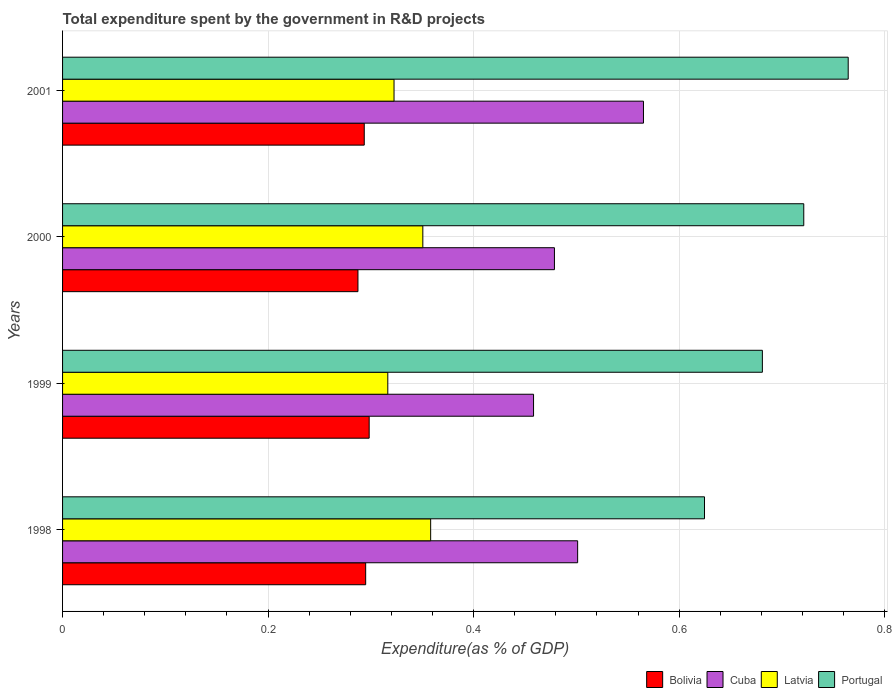How many different coloured bars are there?
Your answer should be compact. 4. How many groups of bars are there?
Your answer should be very brief. 4. Are the number of bars per tick equal to the number of legend labels?
Make the answer very short. Yes. Are the number of bars on each tick of the Y-axis equal?
Your answer should be compact. Yes. How many bars are there on the 2nd tick from the top?
Keep it short and to the point. 4. In how many cases, is the number of bars for a given year not equal to the number of legend labels?
Keep it short and to the point. 0. What is the total expenditure spent by the government in R&D projects in Latvia in 2000?
Your answer should be very brief. 0.35. Across all years, what is the maximum total expenditure spent by the government in R&D projects in Portugal?
Offer a very short reply. 0.76. Across all years, what is the minimum total expenditure spent by the government in R&D projects in Cuba?
Ensure brevity in your answer.  0.46. What is the total total expenditure spent by the government in R&D projects in Cuba in the graph?
Keep it short and to the point. 2. What is the difference between the total expenditure spent by the government in R&D projects in Latvia in 1999 and that in 2001?
Offer a terse response. -0.01. What is the difference between the total expenditure spent by the government in R&D projects in Bolivia in 2000 and the total expenditure spent by the government in R&D projects in Cuba in 2001?
Your answer should be compact. -0.28. What is the average total expenditure spent by the government in R&D projects in Bolivia per year?
Provide a succinct answer. 0.29. In the year 1999, what is the difference between the total expenditure spent by the government in R&D projects in Latvia and total expenditure spent by the government in R&D projects in Bolivia?
Your response must be concise. 0.02. In how many years, is the total expenditure spent by the government in R&D projects in Latvia greater than 0.16 %?
Make the answer very short. 4. What is the ratio of the total expenditure spent by the government in R&D projects in Portugal in 1999 to that in 2001?
Offer a terse response. 0.89. What is the difference between the highest and the second highest total expenditure spent by the government in R&D projects in Latvia?
Offer a very short reply. 0.01. What is the difference between the highest and the lowest total expenditure spent by the government in R&D projects in Portugal?
Provide a succinct answer. 0.14. Is the sum of the total expenditure spent by the government in R&D projects in Portugal in 1998 and 2001 greater than the maximum total expenditure spent by the government in R&D projects in Latvia across all years?
Provide a succinct answer. Yes. Is it the case that in every year, the sum of the total expenditure spent by the government in R&D projects in Cuba and total expenditure spent by the government in R&D projects in Bolivia is greater than the sum of total expenditure spent by the government in R&D projects in Latvia and total expenditure spent by the government in R&D projects in Portugal?
Your answer should be very brief. Yes. What does the 3rd bar from the top in 2001 represents?
Your answer should be very brief. Cuba. What does the 3rd bar from the bottom in 2001 represents?
Your answer should be very brief. Latvia. How many bars are there?
Offer a very short reply. 16. Are all the bars in the graph horizontal?
Give a very brief answer. Yes. Does the graph contain any zero values?
Keep it short and to the point. No. What is the title of the graph?
Keep it short and to the point. Total expenditure spent by the government in R&D projects. Does "Yemen, Rep." appear as one of the legend labels in the graph?
Your response must be concise. No. What is the label or title of the X-axis?
Provide a short and direct response. Expenditure(as % of GDP). What is the label or title of the Y-axis?
Offer a terse response. Years. What is the Expenditure(as % of GDP) of Bolivia in 1998?
Give a very brief answer. 0.29. What is the Expenditure(as % of GDP) of Cuba in 1998?
Ensure brevity in your answer.  0.5. What is the Expenditure(as % of GDP) in Latvia in 1998?
Give a very brief answer. 0.36. What is the Expenditure(as % of GDP) of Portugal in 1998?
Your answer should be very brief. 0.62. What is the Expenditure(as % of GDP) of Bolivia in 1999?
Your answer should be very brief. 0.3. What is the Expenditure(as % of GDP) of Cuba in 1999?
Your answer should be compact. 0.46. What is the Expenditure(as % of GDP) of Latvia in 1999?
Ensure brevity in your answer.  0.32. What is the Expenditure(as % of GDP) of Portugal in 1999?
Offer a very short reply. 0.68. What is the Expenditure(as % of GDP) of Bolivia in 2000?
Offer a terse response. 0.29. What is the Expenditure(as % of GDP) of Cuba in 2000?
Provide a short and direct response. 0.48. What is the Expenditure(as % of GDP) in Latvia in 2000?
Your answer should be very brief. 0.35. What is the Expenditure(as % of GDP) in Portugal in 2000?
Provide a succinct answer. 0.72. What is the Expenditure(as % of GDP) in Bolivia in 2001?
Keep it short and to the point. 0.29. What is the Expenditure(as % of GDP) of Cuba in 2001?
Provide a short and direct response. 0.57. What is the Expenditure(as % of GDP) of Latvia in 2001?
Provide a succinct answer. 0.32. What is the Expenditure(as % of GDP) of Portugal in 2001?
Offer a terse response. 0.76. Across all years, what is the maximum Expenditure(as % of GDP) in Bolivia?
Your answer should be very brief. 0.3. Across all years, what is the maximum Expenditure(as % of GDP) of Cuba?
Make the answer very short. 0.57. Across all years, what is the maximum Expenditure(as % of GDP) in Latvia?
Your response must be concise. 0.36. Across all years, what is the maximum Expenditure(as % of GDP) in Portugal?
Provide a short and direct response. 0.76. Across all years, what is the minimum Expenditure(as % of GDP) in Bolivia?
Offer a very short reply. 0.29. Across all years, what is the minimum Expenditure(as % of GDP) in Cuba?
Your answer should be compact. 0.46. Across all years, what is the minimum Expenditure(as % of GDP) of Latvia?
Provide a succinct answer. 0.32. Across all years, what is the minimum Expenditure(as % of GDP) in Portugal?
Give a very brief answer. 0.62. What is the total Expenditure(as % of GDP) in Bolivia in the graph?
Keep it short and to the point. 1.17. What is the total Expenditure(as % of GDP) in Cuba in the graph?
Provide a succinct answer. 2. What is the total Expenditure(as % of GDP) of Latvia in the graph?
Your answer should be compact. 1.35. What is the total Expenditure(as % of GDP) in Portugal in the graph?
Give a very brief answer. 2.79. What is the difference between the Expenditure(as % of GDP) of Bolivia in 1998 and that in 1999?
Provide a succinct answer. -0. What is the difference between the Expenditure(as % of GDP) of Cuba in 1998 and that in 1999?
Your answer should be compact. 0.04. What is the difference between the Expenditure(as % of GDP) in Latvia in 1998 and that in 1999?
Provide a succinct answer. 0.04. What is the difference between the Expenditure(as % of GDP) of Portugal in 1998 and that in 1999?
Offer a very short reply. -0.06. What is the difference between the Expenditure(as % of GDP) of Bolivia in 1998 and that in 2000?
Provide a succinct answer. 0.01. What is the difference between the Expenditure(as % of GDP) in Cuba in 1998 and that in 2000?
Ensure brevity in your answer.  0.02. What is the difference between the Expenditure(as % of GDP) of Latvia in 1998 and that in 2000?
Your answer should be compact. 0.01. What is the difference between the Expenditure(as % of GDP) in Portugal in 1998 and that in 2000?
Provide a short and direct response. -0.1. What is the difference between the Expenditure(as % of GDP) of Bolivia in 1998 and that in 2001?
Make the answer very short. 0. What is the difference between the Expenditure(as % of GDP) in Cuba in 1998 and that in 2001?
Ensure brevity in your answer.  -0.06. What is the difference between the Expenditure(as % of GDP) in Latvia in 1998 and that in 2001?
Make the answer very short. 0.04. What is the difference between the Expenditure(as % of GDP) in Portugal in 1998 and that in 2001?
Your response must be concise. -0.14. What is the difference between the Expenditure(as % of GDP) of Bolivia in 1999 and that in 2000?
Offer a terse response. 0.01. What is the difference between the Expenditure(as % of GDP) of Cuba in 1999 and that in 2000?
Provide a short and direct response. -0.02. What is the difference between the Expenditure(as % of GDP) in Latvia in 1999 and that in 2000?
Ensure brevity in your answer.  -0.03. What is the difference between the Expenditure(as % of GDP) in Portugal in 1999 and that in 2000?
Offer a terse response. -0.04. What is the difference between the Expenditure(as % of GDP) in Bolivia in 1999 and that in 2001?
Make the answer very short. 0. What is the difference between the Expenditure(as % of GDP) of Cuba in 1999 and that in 2001?
Ensure brevity in your answer.  -0.11. What is the difference between the Expenditure(as % of GDP) in Latvia in 1999 and that in 2001?
Offer a very short reply. -0.01. What is the difference between the Expenditure(as % of GDP) of Portugal in 1999 and that in 2001?
Make the answer very short. -0.08. What is the difference between the Expenditure(as % of GDP) of Bolivia in 2000 and that in 2001?
Ensure brevity in your answer.  -0.01. What is the difference between the Expenditure(as % of GDP) in Cuba in 2000 and that in 2001?
Your answer should be compact. -0.09. What is the difference between the Expenditure(as % of GDP) in Latvia in 2000 and that in 2001?
Offer a very short reply. 0.03. What is the difference between the Expenditure(as % of GDP) in Portugal in 2000 and that in 2001?
Provide a short and direct response. -0.04. What is the difference between the Expenditure(as % of GDP) in Bolivia in 1998 and the Expenditure(as % of GDP) in Cuba in 1999?
Your answer should be very brief. -0.16. What is the difference between the Expenditure(as % of GDP) of Bolivia in 1998 and the Expenditure(as % of GDP) of Latvia in 1999?
Offer a terse response. -0.02. What is the difference between the Expenditure(as % of GDP) in Bolivia in 1998 and the Expenditure(as % of GDP) in Portugal in 1999?
Provide a short and direct response. -0.39. What is the difference between the Expenditure(as % of GDP) in Cuba in 1998 and the Expenditure(as % of GDP) in Latvia in 1999?
Give a very brief answer. 0.18. What is the difference between the Expenditure(as % of GDP) of Cuba in 1998 and the Expenditure(as % of GDP) of Portugal in 1999?
Provide a short and direct response. -0.18. What is the difference between the Expenditure(as % of GDP) in Latvia in 1998 and the Expenditure(as % of GDP) in Portugal in 1999?
Ensure brevity in your answer.  -0.32. What is the difference between the Expenditure(as % of GDP) of Bolivia in 1998 and the Expenditure(as % of GDP) of Cuba in 2000?
Your answer should be compact. -0.18. What is the difference between the Expenditure(as % of GDP) in Bolivia in 1998 and the Expenditure(as % of GDP) in Latvia in 2000?
Provide a short and direct response. -0.06. What is the difference between the Expenditure(as % of GDP) in Bolivia in 1998 and the Expenditure(as % of GDP) in Portugal in 2000?
Keep it short and to the point. -0.43. What is the difference between the Expenditure(as % of GDP) of Cuba in 1998 and the Expenditure(as % of GDP) of Latvia in 2000?
Offer a very short reply. 0.15. What is the difference between the Expenditure(as % of GDP) of Cuba in 1998 and the Expenditure(as % of GDP) of Portugal in 2000?
Your answer should be compact. -0.22. What is the difference between the Expenditure(as % of GDP) in Latvia in 1998 and the Expenditure(as % of GDP) in Portugal in 2000?
Offer a terse response. -0.36. What is the difference between the Expenditure(as % of GDP) in Bolivia in 1998 and the Expenditure(as % of GDP) in Cuba in 2001?
Keep it short and to the point. -0.27. What is the difference between the Expenditure(as % of GDP) in Bolivia in 1998 and the Expenditure(as % of GDP) in Latvia in 2001?
Provide a short and direct response. -0.03. What is the difference between the Expenditure(as % of GDP) of Bolivia in 1998 and the Expenditure(as % of GDP) of Portugal in 2001?
Ensure brevity in your answer.  -0.47. What is the difference between the Expenditure(as % of GDP) of Cuba in 1998 and the Expenditure(as % of GDP) of Latvia in 2001?
Your response must be concise. 0.18. What is the difference between the Expenditure(as % of GDP) of Cuba in 1998 and the Expenditure(as % of GDP) of Portugal in 2001?
Give a very brief answer. -0.26. What is the difference between the Expenditure(as % of GDP) of Latvia in 1998 and the Expenditure(as % of GDP) of Portugal in 2001?
Your answer should be very brief. -0.41. What is the difference between the Expenditure(as % of GDP) in Bolivia in 1999 and the Expenditure(as % of GDP) in Cuba in 2000?
Ensure brevity in your answer.  -0.18. What is the difference between the Expenditure(as % of GDP) of Bolivia in 1999 and the Expenditure(as % of GDP) of Latvia in 2000?
Provide a short and direct response. -0.05. What is the difference between the Expenditure(as % of GDP) in Bolivia in 1999 and the Expenditure(as % of GDP) in Portugal in 2000?
Your response must be concise. -0.42. What is the difference between the Expenditure(as % of GDP) in Cuba in 1999 and the Expenditure(as % of GDP) in Latvia in 2000?
Offer a terse response. 0.11. What is the difference between the Expenditure(as % of GDP) in Cuba in 1999 and the Expenditure(as % of GDP) in Portugal in 2000?
Keep it short and to the point. -0.26. What is the difference between the Expenditure(as % of GDP) in Latvia in 1999 and the Expenditure(as % of GDP) in Portugal in 2000?
Offer a very short reply. -0.4. What is the difference between the Expenditure(as % of GDP) of Bolivia in 1999 and the Expenditure(as % of GDP) of Cuba in 2001?
Offer a very short reply. -0.27. What is the difference between the Expenditure(as % of GDP) of Bolivia in 1999 and the Expenditure(as % of GDP) of Latvia in 2001?
Offer a very short reply. -0.02. What is the difference between the Expenditure(as % of GDP) in Bolivia in 1999 and the Expenditure(as % of GDP) in Portugal in 2001?
Your answer should be compact. -0.47. What is the difference between the Expenditure(as % of GDP) of Cuba in 1999 and the Expenditure(as % of GDP) of Latvia in 2001?
Keep it short and to the point. 0.14. What is the difference between the Expenditure(as % of GDP) in Cuba in 1999 and the Expenditure(as % of GDP) in Portugal in 2001?
Offer a terse response. -0.31. What is the difference between the Expenditure(as % of GDP) in Latvia in 1999 and the Expenditure(as % of GDP) in Portugal in 2001?
Keep it short and to the point. -0.45. What is the difference between the Expenditure(as % of GDP) in Bolivia in 2000 and the Expenditure(as % of GDP) in Cuba in 2001?
Your answer should be compact. -0.28. What is the difference between the Expenditure(as % of GDP) in Bolivia in 2000 and the Expenditure(as % of GDP) in Latvia in 2001?
Keep it short and to the point. -0.04. What is the difference between the Expenditure(as % of GDP) in Bolivia in 2000 and the Expenditure(as % of GDP) in Portugal in 2001?
Your answer should be compact. -0.48. What is the difference between the Expenditure(as % of GDP) in Cuba in 2000 and the Expenditure(as % of GDP) in Latvia in 2001?
Keep it short and to the point. 0.16. What is the difference between the Expenditure(as % of GDP) of Cuba in 2000 and the Expenditure(as % of GDP) of Portugal in 2001?
Provide a succinct answer. -0.29. What is the difference between the Expenditure(as % of GDP) of Latvia in 2000 and the Expenditure(as % of GDP) of Portugal in 2001?
Provide a succinct answer. -0.41. What is the average Expenditure(as % of GDP) in Bolivia per year?
Offer a very short reply. 0.29. What is the average Expenditure(as % of GDP) of Cuba per year?
Your answer should be very brief. 0.5. What is the average Expenditure(as % of GDP) in Latvia per year?
Offer a terse response. 0.34. What is the average Expenditure(as % of GDP) of Portugal per year?
Your answer should be compact. 0.7. In the year 1998, what is the difference between the Expenditure(as % of GDP) of Bolivia and Expenditure(as % of GDP) of Cuba?
Ensure brevity in your answer.  -0.21. In the year 1998, what is the difference between the Expenditure(as % of GDP) of Bolivia and Expenditure(as % of GDP) of Latvia?
Provide a succinct answer. -0.06. In the year 1998, what is the difference between the Expenditure(as % of GDP) of Bolivia and Expenditure(as % of GDP) of Portugal?
Offer a very short reply. -0.33. In the year 1998, what is the difference between the Expenditure(as % of GDP) in Cuba and Expenditure(as % of GDP) in Latvia?
Offer a terse response. 0.14. In the year 1998, what is the difference between the Expenditure(as % of GDP) of Cuba and Expenditure(as % of GDP) of Portugal?
Make the answer very short. -0.12. In the year 1998, what is the difference between the Expenditure(as % of GDP) in Latvia and Expenditure(as % of GDP) in Portugal?
Provide a short and direct response. -0.27. In the year 1999, what is the difference between the Expenditure(as % of GDP) in Bolivia and Expenditure(as % of GDP) in Cuba?
Your answer should be compact. -0.16. In the year 1999, what is the difference between the Expenditure(as % of GDP) of Bolivia and Expenditure(as % of GDP) of Latvia?
Make the answer very short. -0.02. In the year 1999, what is the difference between the Expenditure(as % of GDP) in Bolivia and Expenditure(as % of GDP) in Portugal?
Your answer should be very brief. -0.38. In the year 1999, what is the difference between the Expenditure(as % of GDP) of Cuba and Expenditure(as % of GDP) of Latvia?
Your response must be concise. 0.14. In the year 1999, what is the difference between the Expenditure(as % of GDP) in Cuba and Expenditure(as % of GDP) in Portugal?
Provide a short and direct response. -0.22. In the year 1999, what is the difference between the Expenditure(as % of GDP) of Latvia and Expenditure(as % of GDP) of Portugal?
Provide a short and direct response. -0.36. In the year 2000, what is the difference between the Expenditure(as % of GDP) in Bolivia and Expenditure(as % of GDP) in Cuba?
Offer a terse response. -0.19. In the year 2000, what is the difference between the Expenditure(as % of GDP) of Bolivia and Expenditure(as % of GDP) of Latvia?
Ensure brevity in your answer.  -0.06. In the year 2000, what is the difference between the Expenditure(as % of GDP) in Bolivia and Expenditure(as % of GDP) in Portugal?
Your answer should be very brief. -0.43. In the year 2000, what is the difference between the Expenditure(as % of GDP) in Cuba and Expenditure(as % of GDP) in Latvia?
Your answer should be compact. 0.13. In the year 2000, what is the difference between the Expenditure(as % of GDP) in Cuba and Expenditure(as % of GDP) in Portugal?
Your answer should be compact. -0.24. In the year 2000, what is the difference between the Expenditure(as % of GDP) of Latvia and Expenditure(as % of GDP) of Portugal?
Make the answer very short. -0.37. In the year 2001, what is the difference between the Expenditure(as % of GDP) of Bolivia and Expenditure(as % of GDP) of Cuba?
Offer a very short reply. -0.27. In the year 2001, what is the difference between the Expenditure(as % of GDP) in Bolivia and Expenditure(as % of GDP) in Latvia?
Your answer should be very brief. -0.03. In the year 2001, what is the difference between the Expenditure(as % of GDP) of Bolivia and Expenditure(as % of GDP) of Portugal?
Your response must be concise. -0.47. In the year 2001, what is the difference between the Expenditure(as % of GDP) of Cuba and Expenditure(as % of GDP) of Latvia?
Offer a very short reply. 0.24. In the year 2001, what is the difference between the Expenditure(as % of GDP) of Cuba and Expenditure(as % of GDP) of Portugal?
Offer a very short reply. -0.2. In the year 2001, what is the difference between the Expenditure(as % of GDP) of Latvia and Expenditure(as % of GDP) of Portugal?
Offer a terse response. -0.44. What is the ratio of the Expenditure(as % of GDP) of Bolivia in 1998 to that in 1999?
Give a very brief answer. 0.99. What is the ratio of the Expenditure(as % of GDP) in Cuba in 1998 to that in 1999?
Offer a terse response. 1.09. What is the ratio of the Expenditure(as % of GDP) of Latvia in 1998 to that in 1999?
Your answer should be compact. 1.13. What is the ratio of the Expenditure(as % of GDP) in Portugal in 1998 to that in 1999?
Your answer should be compact. 0.92. What is the ratio of the Expenditure(as % of GDP) of Bolivia in 1998 to that in 2000?
Keep it short and to the point. 1.03. What is the ratio of the Expenditure(as % of GDP) of Cuba in 1998 to that in 2000?
Provide a succinct answer. 1.05. What is the ratio of the Expenditure(as % of GDP) of Latvia in 1998 to that in 2000?
Your answer should be compact. 1.02. What is the ratio of the Expenditure(as % of GDP) of Portugal in 1998 to that in 2000?
Your answer should be very brief. 0.87. What is the ratio of the Expenditure(as % of GDP) of Bolivia in 1998 to that in 2001?
Offer a terse response. 1. What is the ratio of the Expenditure(as % of GDP) in Cuba in 1998 to that in 2001?
Make the answer very short. 0.89. What is the ratio of the Expenditure(as % of GDP) of Latvia in 1998 to that in 2001?
Your response must be concise. 1.11. What is the ratio of the Expenditure(as % of GDP) of Portugal in 1998 to that in 2001?
Your response must be concise. 0.82. What is the ratio of the Expenditure(as % of GDP) of Bolivia in 1999 to that in 2000?
Offer a very short reply. 1.04. What is the ratio of the Expenditure(as % of GDP) of Cuba in 1999 to that in 2000?
Offer a very short reply. 0.96. What is the ratio of the Expenditure(as % of GDP) in Latvia in 1999 to that in 2000?
Ensure brevity in your answer.  0.9. What is the ratio of the Expenditure(as % of GDP) of Portugal in 1999 to that in 2000?
Your answer should be compact. 0.94. What is the ratio of the Expenditure(as % of GDP) in Bolivia in 1999 to that in 2001?
Ensure brevity in your answer.  1.02. What is the ratio of the Expenditure(as % of GDP) of Cuba in 1999 to that in 2001?
Offer a very short reply. 0.81. What is the ratio of the Expenditure(as % of GDP) of Latvia in 1999 to that in 2001?
Your answer should be compact. 0.98. What is the ratio of the Expenditure(as % of GDP) of Portugal in 1999 to that in 2001?
Your answer should be compact. 0.89. What is the ratio of the Expenditure(as % of GDP) in Bolivia in 2000 to that in 2001?
Your answer should be compact. 0.98. What is the ratio of the Expenditure(as % of GDP) in Cuba in 2000 to that in 2001?
Keep it short and to the point. 0.85. What is the ratio of the Expenditure(as % of GDP) in Latvia in 2000 to that in 2001?
Provide a succinct answer. 1.09. What is the ratio of the Expenditure(as % of GDP) of Portugal in 2000 to that in 2001?
Make the answer very short. 0.94. What is the difference between the highest and the second highest Expenditure(as % of GDP) in Bolivia?
Provide a short and direct response. 0. What is the difference between the highest and the second highest Expenditure(as % of GDP) in Cuba?
Your response must be concise. 0.06. What is the difference between the highest and the second highest Expenditure(as % of GDP) in Latvia?
Your response must be concise. 0.01. What is the difference between the highest and the second highest Expenditure(as % of GDP) of Portugal?
Give a very brief answer. 0.04. What is the difference between the highest and the lowest Expenditure(as % of GDP) in Bolivia?
Your answer should be compact. 0.01. What is the difference between the highest and the lowest Expenditure(as % of GDP) of Cuba?
Ensure brevity in your answer.  0.11. What is the difference between the highest and the lowest Expenditure(as % of GDP) of Latvia?
Your answer should be very brief. 0.04. What is the difference between the highest and the lowest Expenditure(as % of GDP) of Portugal?
Offer a very short reply. 0.14. 